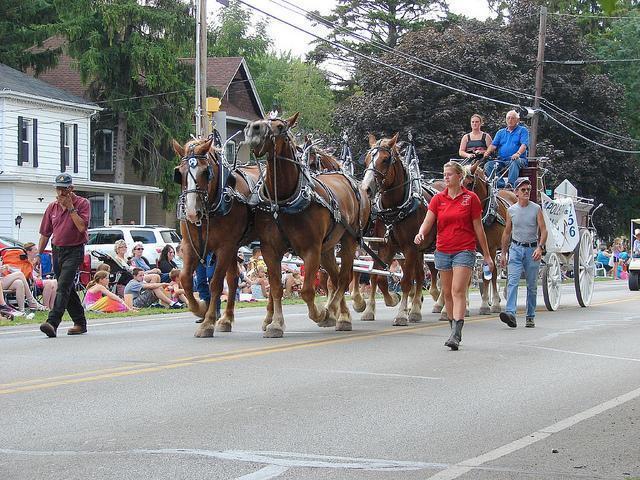How many horses are seen?
Give a very brief answer. 4. How many horses can you see?
Give a very brief answer. 4. How many people can you see?
Give a very brief answer. 5. How many vases are there?
Give a very brief answer. 0. 